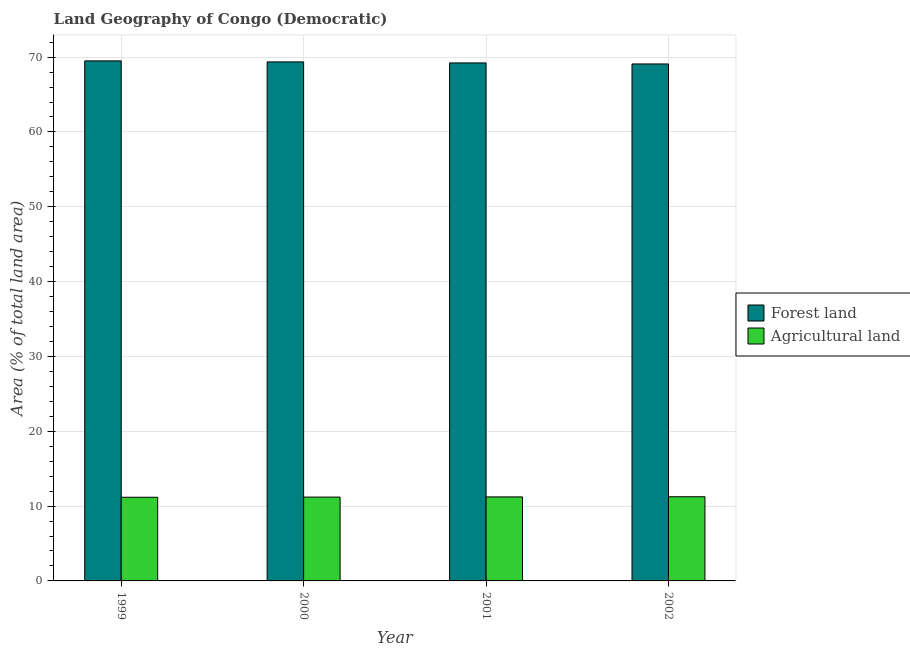How many different coloured bars are there?
Your response must be concise. 2. How many groups of bars are there?
Your answer should be compact. 4. Are the number of bars on each tick of the X-axis equal?
Offer a very short reply. Yes. How many bars are there on the 2nd tick from the left?
Make the answer very short. 2. In how many cases, is the number of bars for a given year not equal to the number of legend labels?
Offer a terse response. 0. What is the percentage of land area under forests in 2001?
Give a very brief answer. 69.23. Across all years, what is the maximum percentage of land area under forests?
Provide a succinct answer. 69.5. Across all years, what is the minimum percentage of land area under forests?
Provide a succinct answer. 69.09. In which year was the percentage of land area under forests maximum?
Give a very brief answer. 1999. What is the total percentage of land area under agriculture in the graph?
Offer a terse response. 44.86. What is the difference between the percentage of land area under forests in 2001 and that in 2002?
Give a very brief answer. 0.14. What is the difference between the percentage of land area under agriculture in 2002 and the percentage of land area under forests in 2000?
Provide a succinct answer. 0.04. What is the average percentage of land area under forests per year?
Provide a succinct answer. 69.29. In the year 2000, what is the difference between the percentage of land area under agriculture and percentage of land area under forests?
Your answer should be very brief. 0. In how many years, is the percentage of land area under agriculture greater than 8 %?
Give a very brief answer. 4. What is the ratio of the percentage of land area under agriculture in 1999 to that in 2002?
Provide a succinct answer. 0.99. Is the percentage of land area under agriculture in 2000 less than that in 2001?
Make the answer very short. Yes. Is the difference between the percentage of land area under forests in 2000 and 2001 greater than the difference between the percentage of land area under agriculture in 2000 and 2001?
Provide a succinct answer. No. What is the difference between the highest and the second highest percentage of land area under forests?
Provide a succinct answer. 0.14. What is the difference between the highest and the lowest percentage of land area under agriculture?
Your answer should be compact. 0.07. In how many years, is the percentage of land area under agriculture greater than the average percentage of land area under agriculture taken over all years?
Provide a short and direct response. 2. What does the 2nd bar from the left in 2002 represents?
Provide a succinct answer. Agricultural land. What does the 2nd bar from the right in 2000 represents?
Keep it short and to the point. Forest land. Are all the bars in the graph horizontal?
Provide a succinct answer. No. What is the difference between two consecutive major ticks on the Y-axis?
Give a very brief answer. 10. Where does the legend appear in the graph?
Keep it short and to the point. Center right. How many legend labels are there?
Offer a terse response. 2. What is the title of the graph?
Keep it short and to the point. Land Geography of Congo (Democratic). What is the label or title of the Y-axis?
Your answer should be compact. Area (% of total land area). What is the Area (% of total land area) in Forest land in 1999?
Your answer should be compact. 69.5. What is the Area (% of total land area) of Agricultural land in 1999?
Ensure brevity in your answer.  11.18. What is the Area (% of total land area) in Forest land in 2000?
Your answer should be very brief. 69.36. What is the Area (% of total land area) in Agricultural land in 2000?
Your answer should be very brief. 11.2. What is the Area (% of total land area) in Forest land in 2001?
Keep it short and to the point. 69.23. What is the Area (% of total land area) of Agricultural land in 2001?
Provide a succinct answer. 11.23. What is the Area (% of total land area) of Forest land in 2002?
Offer a terse response. 69.09. What is the Area (% of total land area) in Agricultural land in 2002?
Provide a short and direct response. 11.25. Across all years, what is the maximum Area (% of total land area) in Forest land?
Offer a very short reply. 69.5. Across all years, what is the maximum Area (% of total land area) of Agricultural land?
Your answer should be compact. 11.25. Across all years, what is the minimum Area (% of total land area) of Forest land?
Your answer should be very brief. 69.09. Across all years, what is the minimum Area (% of total land area) in Agricultural land?
Offer a terse response. 11.18. What is the total Area (% of total land area) in Forest land in the graph?
Your answer should be very brief. 277.18. What is the total Area (% of total land area) of Agricultural land in the graph?
Offer a very short reply. 44.86. What is the difference between the Area (% of total land area) in Forest land in 1999 and that in 2000?
Your answer should be compact. 0.14. What is the difference between the Area (% of total land area) of Agricultural land in 1999 and that in 2000?
Provide a succinct answer. -0.02. What is the difference between the Area (% of total land area) in Forest land in 1999 and that in 2001?
Make the answer very short. 0.27. What is the difference between the Area (% of total land area) of Agricultural land in 1999 and that in 2001?
Offer a very short reply. -0.04. What is the difference between the Area (% of total land area) in Forest land in 1999 and that in 2002?
Offer a very short reply. 0.41. What is the difference between the Area (% of total land area) of Agricultural land in 1999 and that in 2002?
Make the answer very short. -0.07. What is the difference between the Area (% of total land area) in Forest land in 2000 and that in 2001?
Make the answer very short. 0.14. What is the difference between the Area (% of total land area) of Agricultural land in 2000 and that in 2001?
Offer a very short reply. -0.02. What is the difference between the Area (% of total land area) of Forest land in 2000 and that in 2002?
Your answer should be compact. 0.27. What is the difference between the Area (% of total land area) in Agricultural land in 2000 and that in 2002?
Provide a short and direct response. -0.04. What is the difference between the Area (% of total land area) in Forest land in 2001 and that in 2002?
Provide a short and direct response. 0.14. What is the difference between the Area (% of total land area) of Agricultural land in 2001 and that in 2002?
Offer a terse response. -0.02. What is the difference between the Area (% of total land area) of Forest land in 1999 and the Area (% of total land area) of Agricultural land in 2000?
Give a very brief answer. 58.3. What is the difference between the Area (% of total land area) of Forest land in 1999 and the Area (% of total land area) of Agricultural land in 2001?
Your answer should be very brief. 58.27. What is the difference between the Area (% of total land area) of Forest land in 1999 and the Area (% of total land area) of Agricultural land in 2002?
Keep it short and to the point. 58.25. What is the difference between the Area (% of total land area) of Forest land in 2000 and the Area (% of total land area) of Agricultural land in 2001?
Offer a very short reply. 58.14. What is the difference between the Area (% of total land area) of Forest land in 2000 and the Area (% of total land area) of Agricultural land in 2002?
Ensure brevity in your answer.  58.11. What is the difference between the Area (% of total land area) in Forest land in 2001 and the Area (% of total land area) in Agricultural land in 2002?
Offer a terse response. 57.98. What is the average Area (% of total land area) of Forest land per year?
Provide a short and direct response. 69.29. What is the average Area (% of total land area) in Agricultural land per year?
Give a very brief answer. 11.21. In the year 1999, what is the difference between the Area (% of total land area) of Forest land and Area (% of total land area) of Agricultural land?
Your response must be concise. 58.32. In the year 2000, what is the difference between the Area (% of total land area) of Forest land and Area (% of total land area) of Agricultural land?
Provide a short and direct response. 58.16. In the year 2001, what is the difference between the Area (% of total land area) of Forest land and Area (% of total land area) of Agricultural land?
Provide a succinct answer. 58. In the year 2002, what is the difference between the Area (% of total land area) in Forest land and Area (% of total land area) in Agricultural land?
Offer a very short reply. 57.84. What is the ratio of the Area (% of total land area) in Agricultural land in 1999 to that in 2000?
Offer a very short reply. 1. What is the ratio of the Area (% of total land area) in Agricultural land in 1999 to that in 2001?
Provide a short and direct response. 1. What is the ratio of the Area (% of total land area) of Agricultural land in 1999 to that in 2002?
Keep it short and to the point. 0.99. What is the ratio of the Area (% of total land area) of Agricultural land in 2000 to that in 2001?
Provide a short and direct response. 1. What is the ratio of the Area (% of total land area) of Forest land in 2001 to that in 2002?
Provide a short and direct response. 1. What is the difference between the highest and the second highest Area (% of total land area) of Forest land?
Provide a succinct answer. 0.14. What is the difference between the highest and the second highest Area (% of total land area) of Agricultural land?
Your answer should be compact. 0.02. What is the difference between the highest and the lowest Area (% of total land area) of Forest land?
Your response must be concise. 0.41. What is the difference between the highest and the lowest Area (% of total land area) of Agricultural land?
Your answer should be very brief. 0.07. 